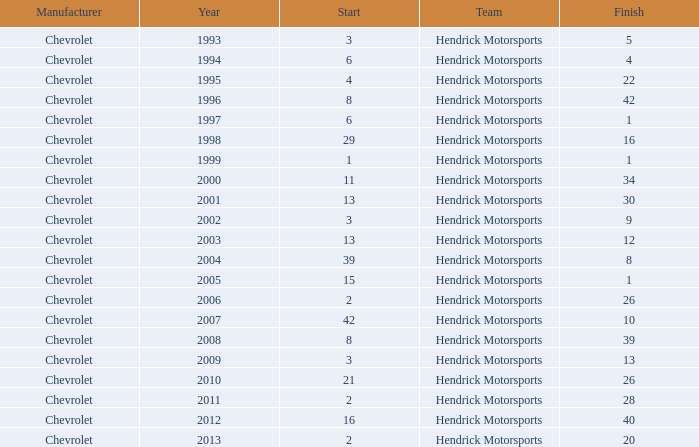What was Jeff's finish in 2011? 28.0. 